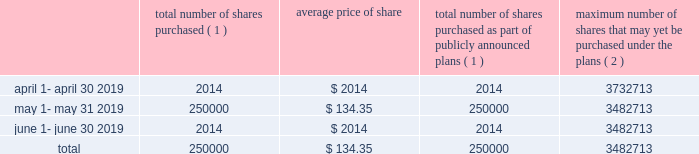J a c k h e n r y .
C o m 1 5 market for registrant 2019s common equity , related stockholder matters and issuer purchases of equity securities the company 2019s common stock is quoted on the nasdaq global select market ( 201cnasdaq 201d ) under the symbol 201cjkhy 201d .
The company established a practice of paying quarterly dividends at the end of fiscal 1990 and has paid dividends with respect to every quarter since that time .
The declaration and payment of any future dividends will continue to be at the discretion of our board of directors and will depend upon , among other factors , our earnings , capital requirements , contractual restrictions , and operating and financial condition .
The company does not currently foresee any changes in its dividend practices .
On august 15 , 2019 , there were approximately 145300 holders of the company 2019s common stock , including individual participants in security position listings .
On that same date the last sale price of the common shares as reported on nasdaq was $ 141.94 per share .
Issuer purchases of equity securities the following shares of the company were repurchased during the quarter ended june 30 , 2019 : total number of shares purchased ( 1 ) average price of total number of shares purchased as part of publicly announced plans ( 1 ) maximum number of shares that may yet be purchased under the plans ( 2 ) .
( 1 ) 250000 shares were purchased through a publicly announced repurchase plan .
There were no shares surrendered to the company to satisfy tax withholding obligations in connection with employee restricted stock awards .
( 2 ) total stock repurchase authorizations approved by the company 2019s board of directors as of february 17 , 2015 were for 30.0 million shares .
These authorizations have no specific dollar or share price targets and no expiration dates. .
On august 15 , 2019 , what was the total market value of the approximately 145300 shares of the company 2019s common stock as reported on nasdaq ? 
Computations: (141.94 * 145300)
Answer: 20623882.0. 